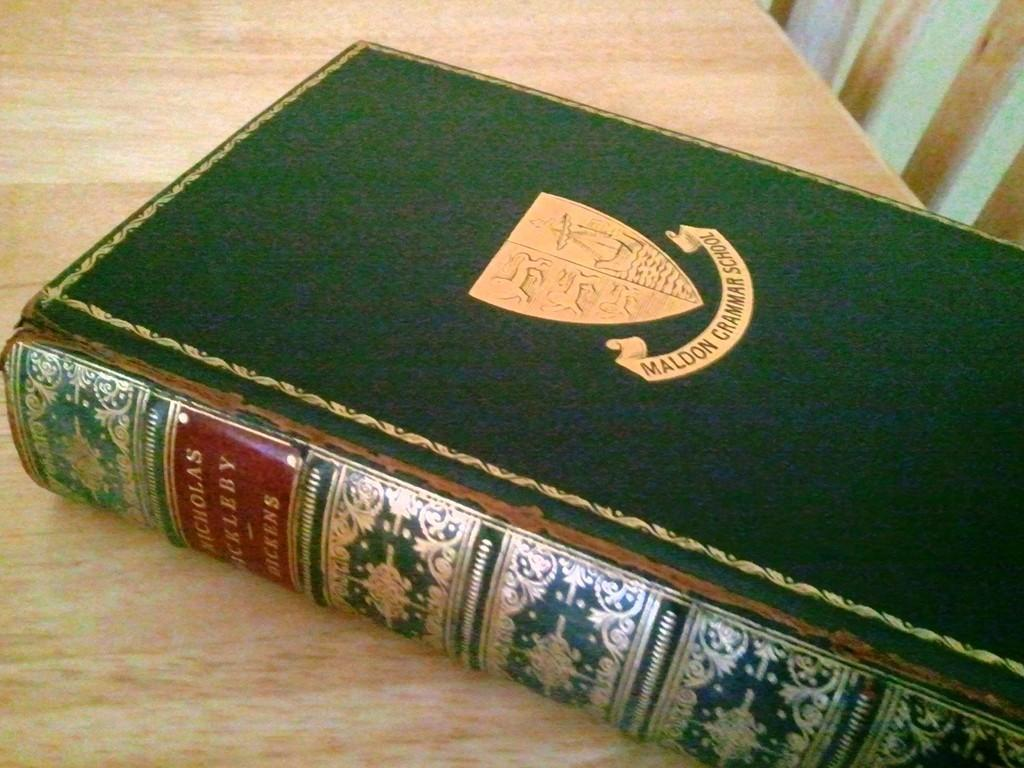<image>
Present a compact description of the photo's key features. A green book that says Maldon Grammar School. 